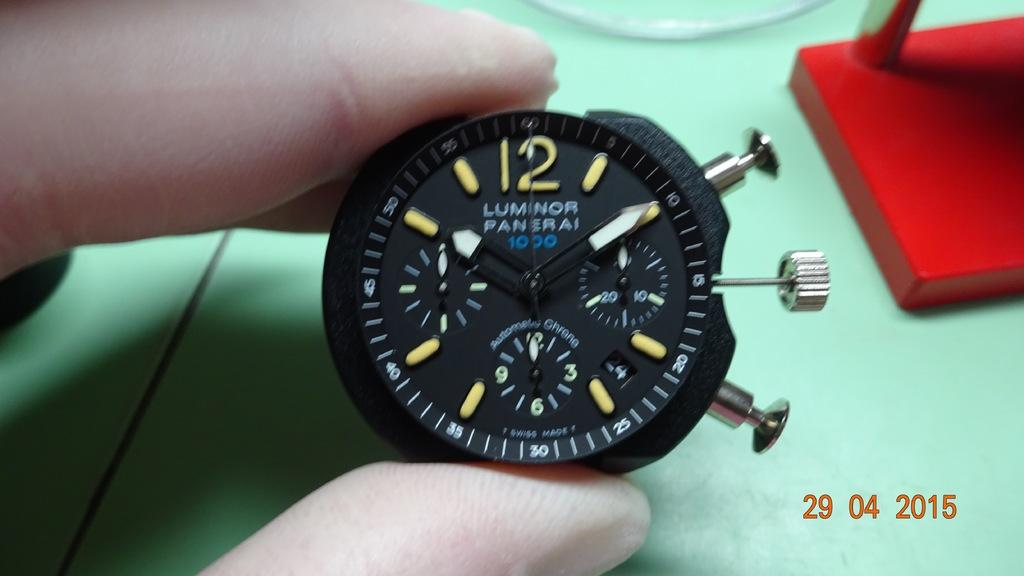Provide a one-sentence caption for the provided image. A person is holding a Luminor Panserai watch face. 